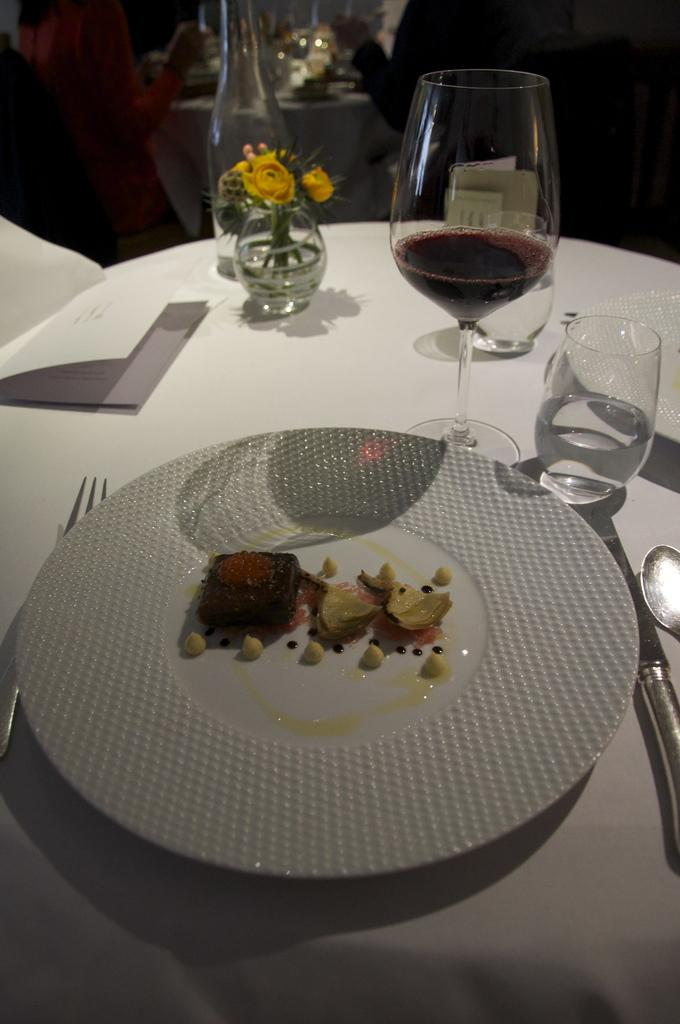What piece of furniture is present in the image? There is a table in the image. What is on the table? There is a plate with food, a fork, a spoon, a knife, 3 glasses, a bottle, and a flower in a vase on the table. How many utensils are on the table? There are 3 utensils on the table: a fork, a spoon, and a knife. How many glasses are on the table? There are 3 glasses on the table. What type of science experiment is being conducted in the image? There is no science experiment present in the image; it features a table with various items on it. How many curtains are hanging in the image? There are no curtains present in the image. 